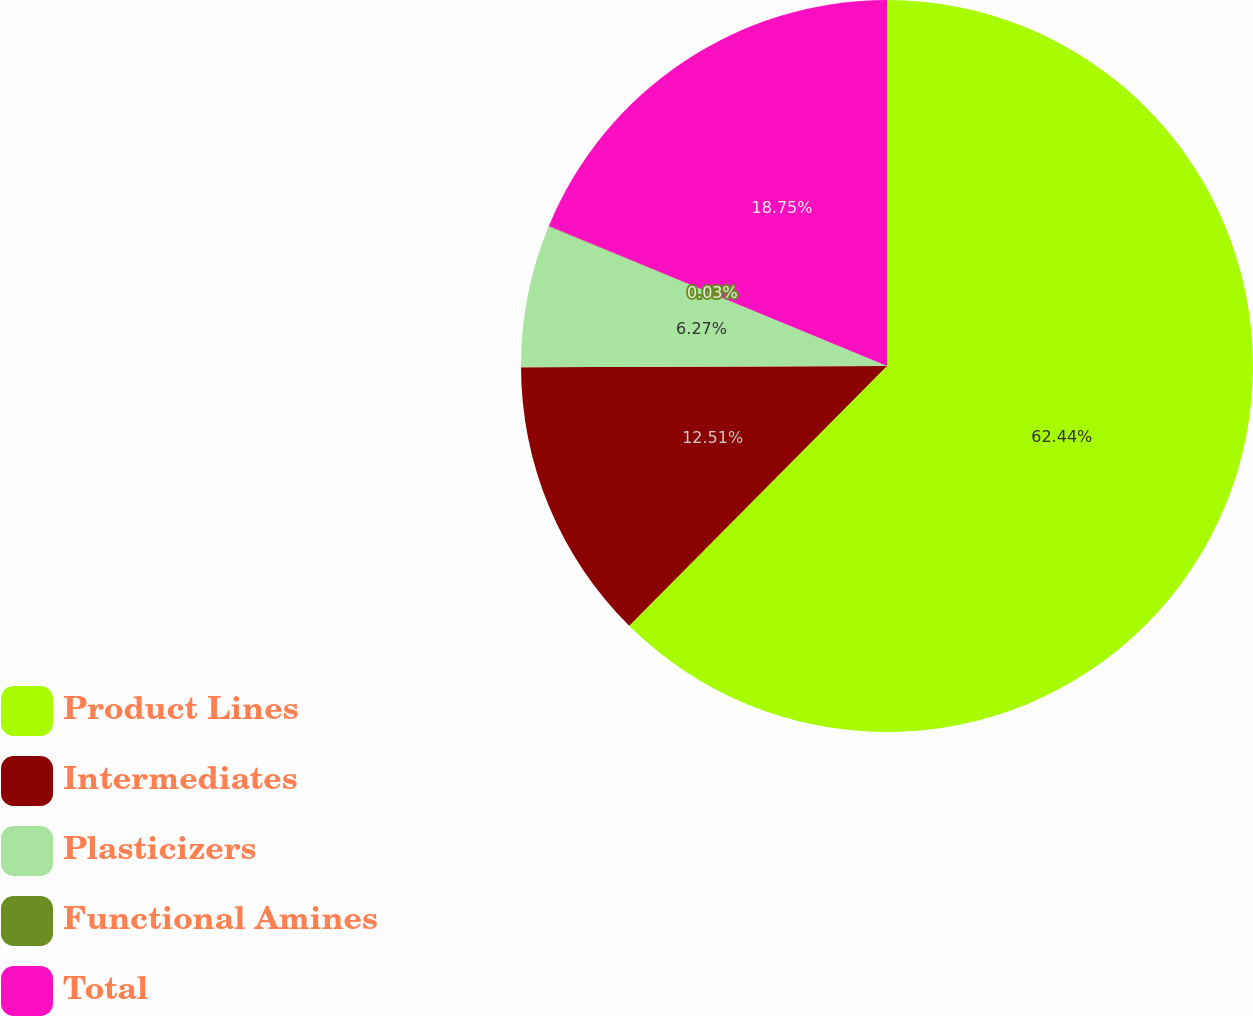<chart> <loc_0><loc_0><loc_500><loc_500><pie_chart><fcel>Product Lines<fcel>Intermediates<fcel>Plasticizers<fcel>Functional Amines<fcel>Total<nl><fcel>62.43%<fcel>12.51%<fcel>6.27%<fcel>0.03%<fcel>18.75%<nl></chart> 